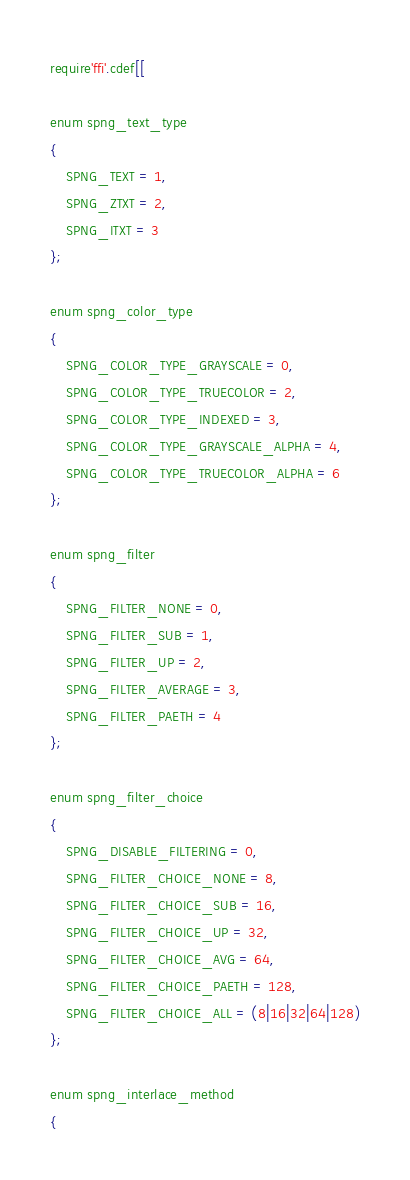Convert code to text. <code><loc_0><loc_0><loc_500><loc_500><_Lua_>require'ffi'.cdef[[

enum spng_text_type
{
	SPNG_TEXT = 1,
	SPNG_ZTXT = 2,
	SPNG_ITXT = 3
};

enum spng_color_type
{
	SPNG_COLOR_TYPE_GRAYSCALE = 0,
	SPNG_COLOR_TYPE_TRUECOLOR = 2,
	SPNG_COLOR_TYPE_INDEXED = 3,
	SPNG_COLOR_TYPE_GRAYSCALE_ALPHA = 4,
	SPNG_COLOR_TYPE_TRUECOLOR_ALPHA = 6
};

enum spng_filter
{
	SPNG_FILTER_NONE = 0,
	SPNG_FILTER_SUB = 1,
	SPNG_FILTER_UP = 2,
	SPNG_FILTER_AVERAGE = 3,
	SPNG_FILTER_PAETH = 4
};

enum spng_filter_choice
{
	SPNG_DISABLE_FILTERING = 0,
	SPNG_FILTER_CHOICE_NONE = 8,
	SPNG_FILTER_CHOICE_SUB = 16,
	SPNG_FILTER_CHOICE_UP = 32,
	SPNG_FILTER_CHOICE_AVG = 64,
	SPNG_FILTER_CHOICE_PAETH = 128,
	SPNG_FILTER_CHOICE_ALL = (8|16|32|64|128)
};

enum spng_interlace_method
{</code> 